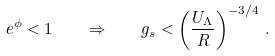<formula> <loc_0><loc_0><loc_500><loc_500>e ^ { \phi } < 1 \quad \Rightarrow \quad g _ { s } < \left ( \frac { U _ { \Lambda } } { R } \right ) ^ { - 3 / 4 } \, .</formula> 